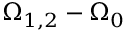<formula> <loc_0><loc_0><loc_500><loc_500>\Omega _ { 1 , 2 } - \Omega _ { 0 }</formula> 